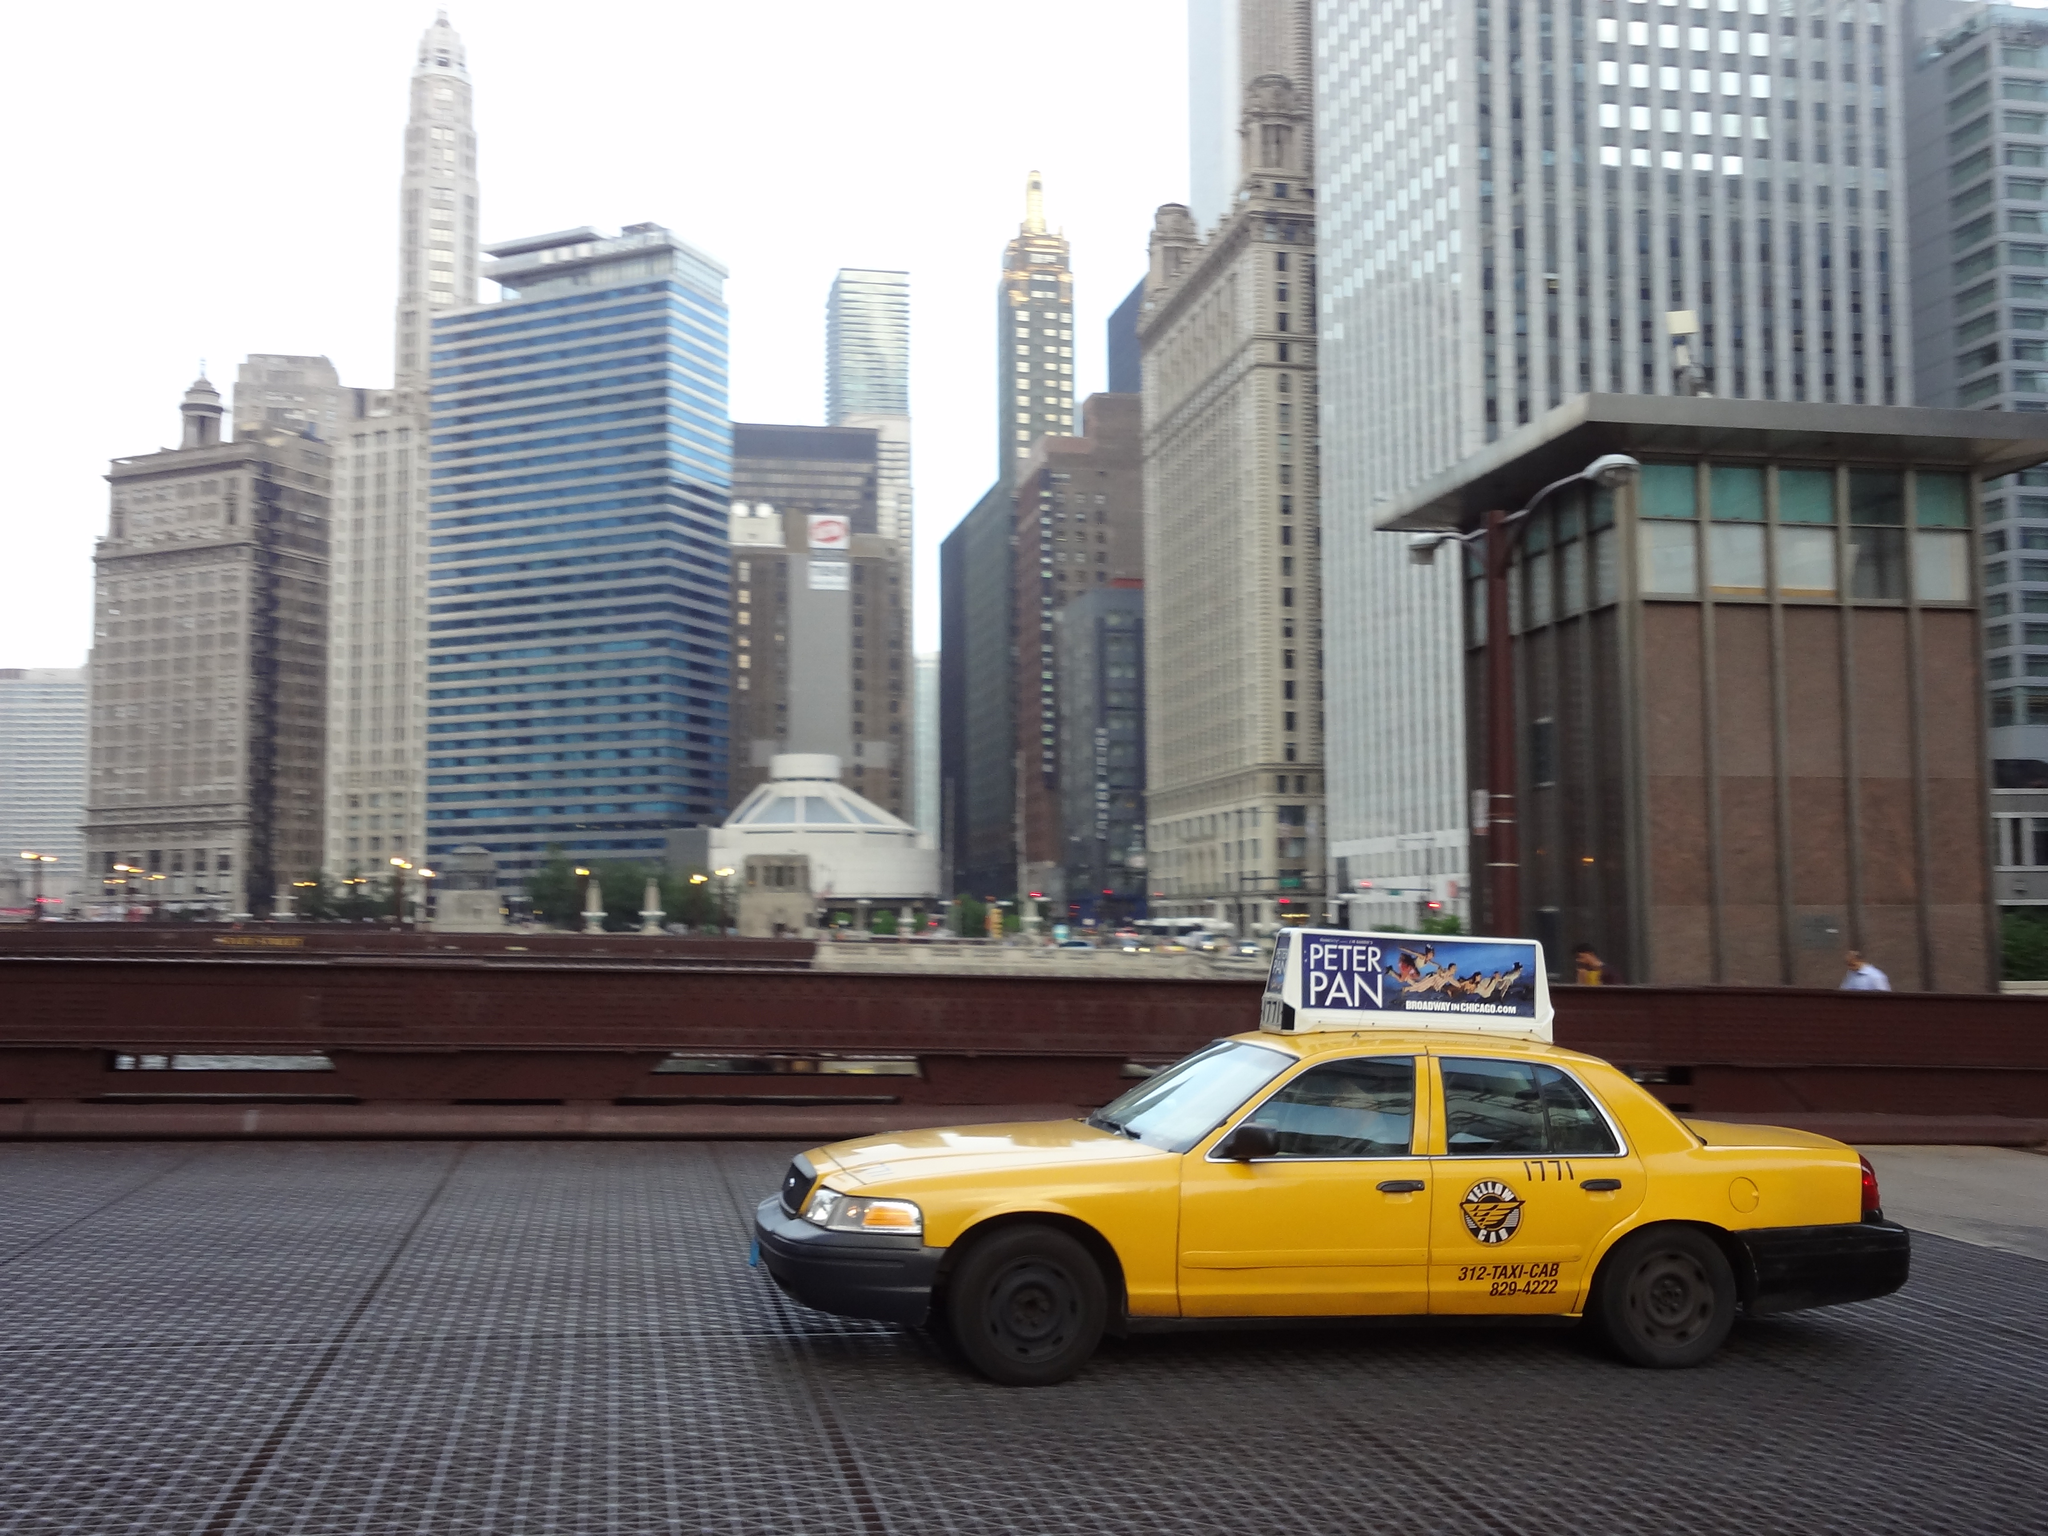Provide a one-sentence caption for the provided image. A taxi travels down a street with a Peter Pan advertisement mounted on top of it. 